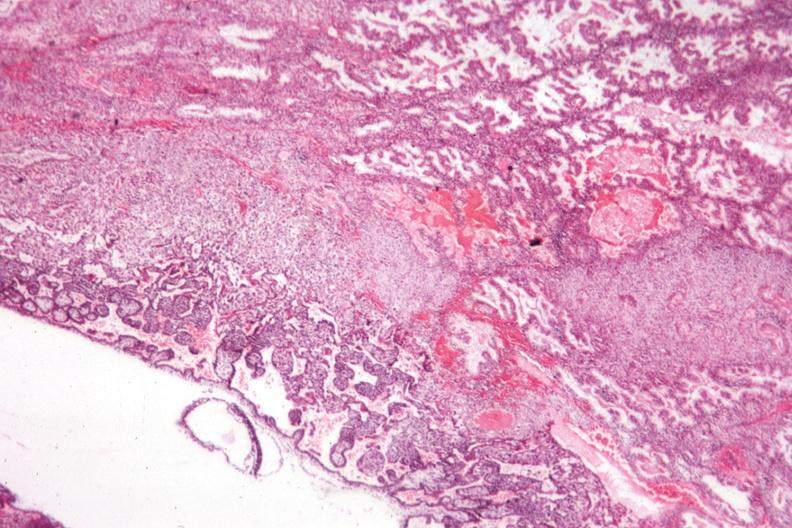does aorta show shows early placental development?
Answer the question using a single word or phrase. No 